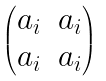<formula> <loc_0><loc_0><loc_500><loc_500>\begin{pmatrix} a _ { i } & a _ { i } \\ a _ { i } & a _ { i } \end{pmatrix}</formula> 